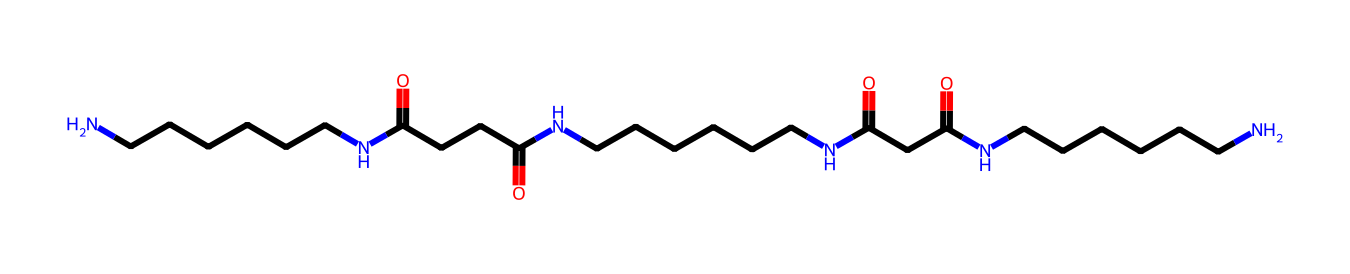what is the main functional group present in this chemical structure? The presence of "C(=O)" in the structure indicates carbonyl groups. The multiple carbonyls suggest that they belong to amide functional groups, as they are adjacent to nitrogen atoms.
Answer: amide how many nitrogen atoms are in this chemical structure? By analyzing the SMILES, we can count the nitrogen atoms, which are represented as 'N'. In this structure, there are three occurrences of 'N'.
Answer: three what is the total number of carbon atoms in the structure? Counting the carbon atoms represented by 'C' in the SMILES notation reveals a total of 18 carbon atoms.
Answer: eighteen what property makes nylon fibers suitable for office chair upholstery? The multiple amide bonds and the long hydrocarbon chains provide nylon with high tensile strength and durability, making it suitable for upholstery.
Answer: durability which part of the structure contributes to the resilience of nylon fibers? The long repeating units of amide bonds create strong intermolecular forces, enhancing the resilience and strength of the nylon fibers.
Answer: amide bonds how many carbonyl groups are present in this chemical structure? By identifying the number of 'C(=O)' in the SMILES representation, we can determine that there are four carbonyl groups in total.
Answer: four is this chemical structure linear or branched? Upon inspection, the structure shows a continuous chain with branching only in specific positions due to the presence of nitrogen and carbonyls, indicating a branched structure.
Answer: branched 